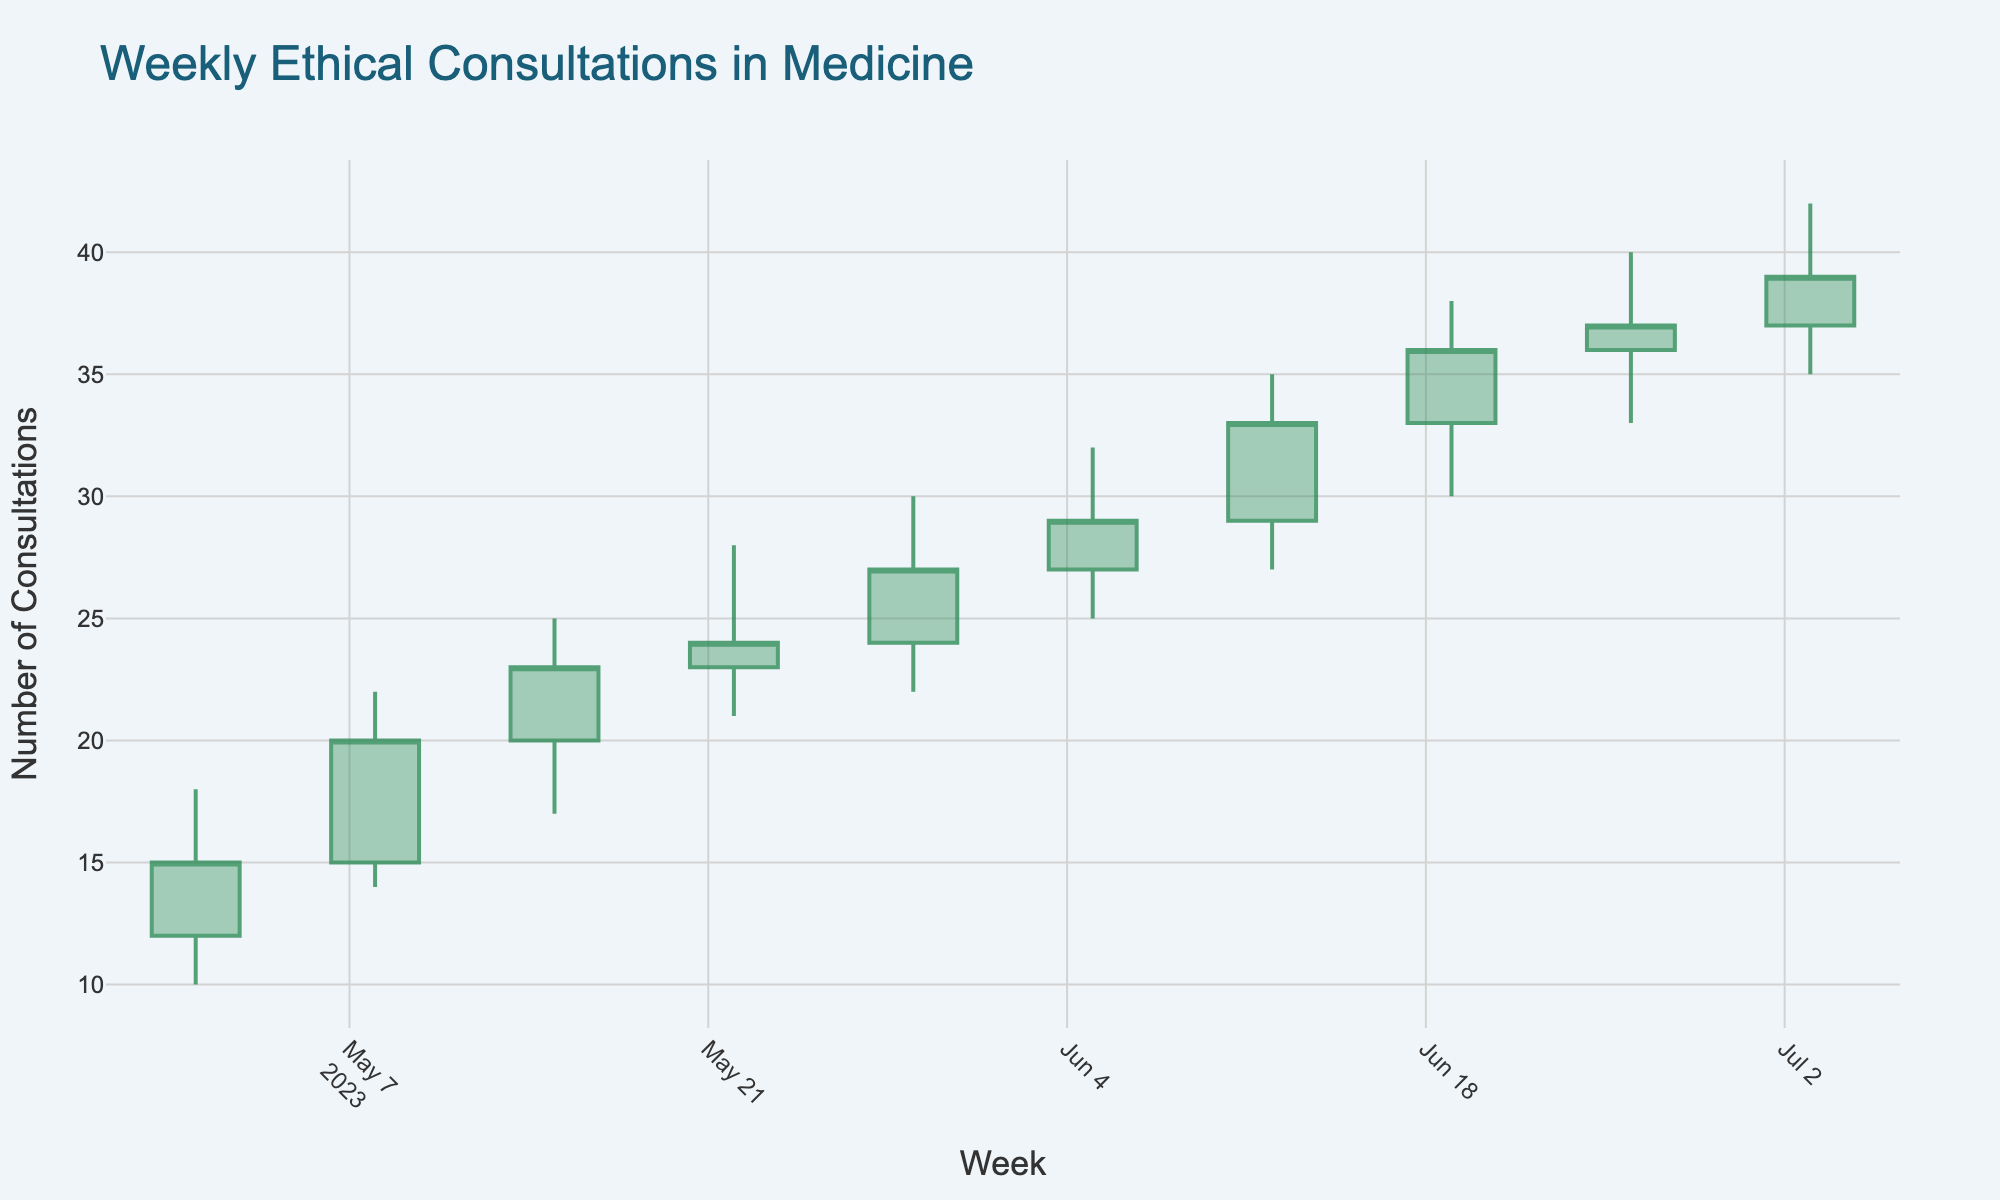What is the title of the OHLC chart? The title is typically found at the top of the chart, written in a large and prominent font to ensure it is noticeable and informative.
Answer: Weekly Ethical Consultations in Medicine How many weeks of data are shown in the chart? This can be determined by counting the data points along the x-axis, which represent the weeks.
Answer: 10 What is the range of the highest value observed in the OHLC chart? The highest value is found by looking at the 'High' data points in each candlestick and identifying the maximum value reached. It spans from a minimum of 18 to a maximum of 42 over the weeks.
Answer: 10 What is the range of the y-axis in the OHLC chart? By looking at the y-axis, you can identify the lowest and highest values it covers, providing the complete range of the values shown.
Answer: 10 to 40 In which week did the number of consultations show the largest increase from the opening value to the closing value? Find the week where the difference between the 'Close' and 'Open' values is the greatest. Subtract the 'Open' value from the 'Close' value for each week and compare. The week with the highest difference is the target. For instance, 2023-06-12 has an increase of 4 consultations.
Answer: 2023-06-12 How does the number of consultations change from the beginning to the end of the date range (from 2023-05-01 to 2023-07-03)? Compare the 'Open' value of the first week (2023-05-01) and the 'Close' value of the last week (2023-07-03) to see the overall change in the number of consultations over the period. The difference shows the net change.
Answer: It increased from 12 to 39 What is the average 'Open' value across all weeks? Add all the 'Open' values and divide by the number of weeks (10) to get the average. (12+15+20+23+24+27+29+33+36+37)/10 = 25.6
Answer: 25.6 Which week experienced the smallest range between the highest and lowest number of consultations? Calculate the difference between 'High' and 'Low' values for each week, and identify the week with the smallest range. For example, 2023-06-26 has a range of 7 (40-33).
Answer: 2023-06-26 During which week was there a decrease in the number of consultations from 'Open' to 'Close'? Look for a week where the 'Open' value is greater than the 'Close' value. This indicates a decrease in the number of consultations from the start to the end of that week.
Answer: There are no weeks with a decrease Was there any week where the low value was higher than the previous week's high value? Compare the 'Low' value of each week with the 'High' value of the previous week, and identify if there is any instance where the 'Low' is greater than the previous week's 'High'.
Answer: No 